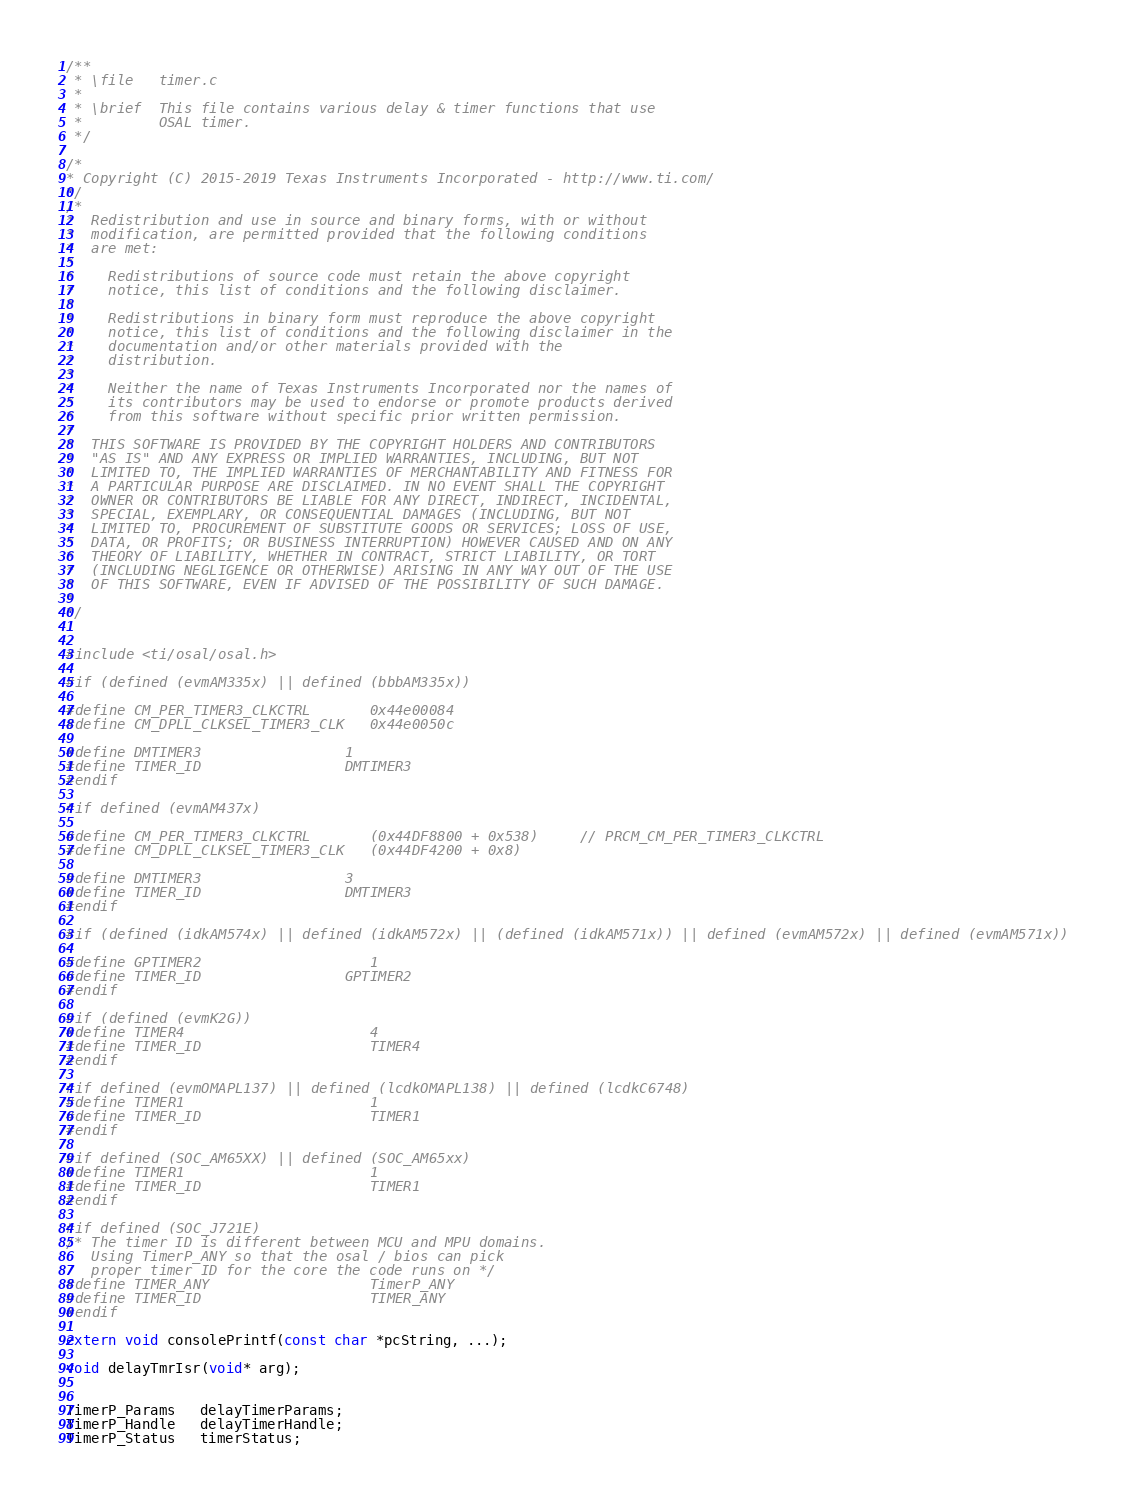Convert code to text. <code><loc_0><loc_0><loc_500><loc_500><_C_>/**
 * \file   timer.c
 *
 * \brief  This file contains various delay & timer functions that use
 *         OSAL timer.
 */

/*
* Copyright (C) 2015-2019 Texas Instruments Incorporated - http://www.ti.com/
*/
/*
*  Redistribution and use in source and binary forms, with or without
*  modification, are permitted provided that the following conditions
*  are met:
*
*    Redistributions of source code must retain the above copyright
*    notice, this list of conditions and the following disclaimer.
*
*    Redistributions in binary form must reproduce the above copyright
*    notice, this list of conditions and the following disclaimer in the
*    documentation and/or other materials provided with the
*    distribution.
*
*    Neither the name of Texas Instruments Incorporated nor the names of
*    its contributors may be used to endorse or promote products derived
*    from this software without specific prior written permission.
*
*  THIS SOFTWARE IS PROVIDED BY THE COPYRIGHT HOLDERS AND CONTRIBUTORS
*  "AS IS" AND ANY EXPRESS OR IMPLIED WARRANTIES, INCLUDING, BUT NOT
*  LIMITED TO, THE IMPLIED WARRANTIES OF MERCHANTABILITY AND FITNESS FOR
*  A PARTICULAR PURPOSE ARE DISCLAIMED. IN NO EVENT SHALL THE COPYRIGHT
*  OWNER OR CONTRIBUTORS BE LIABLE FOR ANY DIRECT, INDIRECT, INCIDENTAL,
*  SPECIAL, EXEMPLARY, OR CONSEQUENTIAL DAMAGES (INCLUDING, BUT NOT
*  LIMITED TO, PROCUREMENT OF SUBSTITUTE GOODS OR SERVICES; LOSS OF USE,
*  DATA, OR PROFITS; OR BUSINESS INTERRUPTION) HOWEVER CAUSED AND ON ANY
*  THEORY OF LIABILITY, WHETHER IN CONTRACT, STRICT LIABILITY, OR TORT
*  (INCLUDING NEGLIGENCE OR OTHERWISE) ARISING IN ANY WAY OUT OF THE USE
*  OF THIS SOFTWARE, EVEN IF ADVISED OF THE POSSIBILITY OF SUCH DAMAGE.
*
*/


#include <ti/osal/osal.h>

#if (defined (evmAM335x) || defined (bbbAM335x))

#define CM_PER_TIMER3_CLKCTRL       0x44e00084
#define CM_DPLL_CLKSEL_TIMER3_CLK   0x44e0050c

#define DMTIMER3					1
#define TIMER_ID					DMTIMER3
#endif

#if defined (evmAM437x)

#define CM_PER_TIMER3_CLKCTRL       (0x44DF8800 + 0x538)		// PRCM_CM_PER_TIMER3_CLKCTRL
#define CM_DPLL_CLKSEL_TIMER3_CLK   (0x44DF4200 + 0x8)

#define DMTIMER3					3
#define TIMER_ID					DMTIMER3
#endif

#if (defined (idkAM574x) || defined (idkAM572x) || (defined (idkAM571x)) || defined (evmAM572x) || defined (evmAM571x))

#define GPTIMER2                    1
#define TIMER_ID					GPTIMER2
#endif

#if (defined (evmK2G))
#define TIMER4                      4       
#define TIMER_ID                    TIMER4
#endif

#if defined (evmOMAPL137) || defined (lcdkOMAPL138) || defined (lcdkC6748)
#define TIMER1                      1
#define TIMER_ID                    TIMER1
#endif

#if defined (SOC_AM65XX) || defined (SOC_AM65xx)
#define TIMER1                      1
#define TIMER_ID                    TIMER1
#endif

#if defined (SOC_J721E)
/* The timer ID is different between MCU and MPU domains.
   Using TimerP_ANY so that the osal / bios can pick
   proper timer ID for the core the code runs on */
#define TIMER_ANY                   TimerP_ANY
#define TIMER_ID                    TIMER_ANY
#endif

extern void consolePrintf(const char *pcString, ...);

void delayTmrIsr(void* arg);


TimerP_Params   delayTimerParams;
TimerP_Handle   delayTimerHandle;
TimerP_Status   timerStatus;</code> 